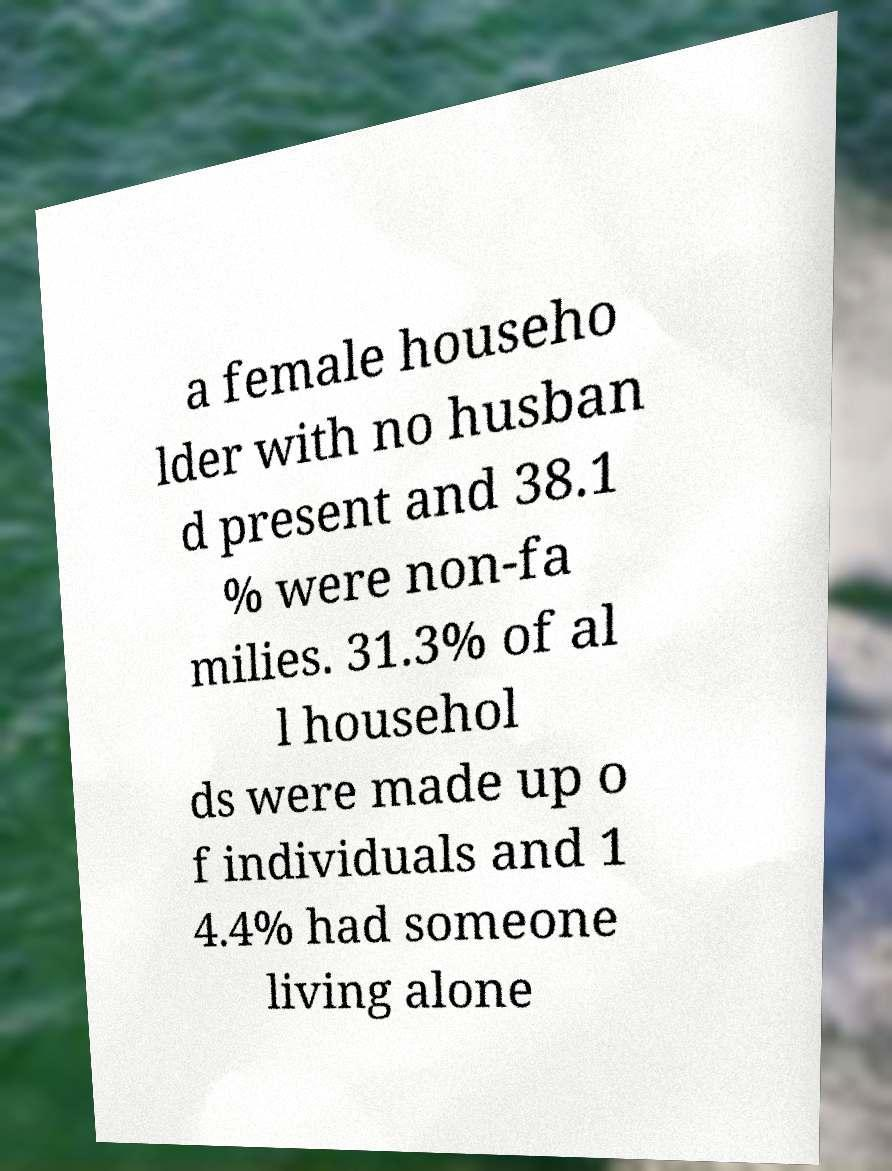I need the written content from this picture converted into text. Can you do that? a female househo lder with no husban d present and 38.1 % were non-fa milies. 31.3% of al l househol ds were made up o f individuals and 1 4.4% had someone living alone 